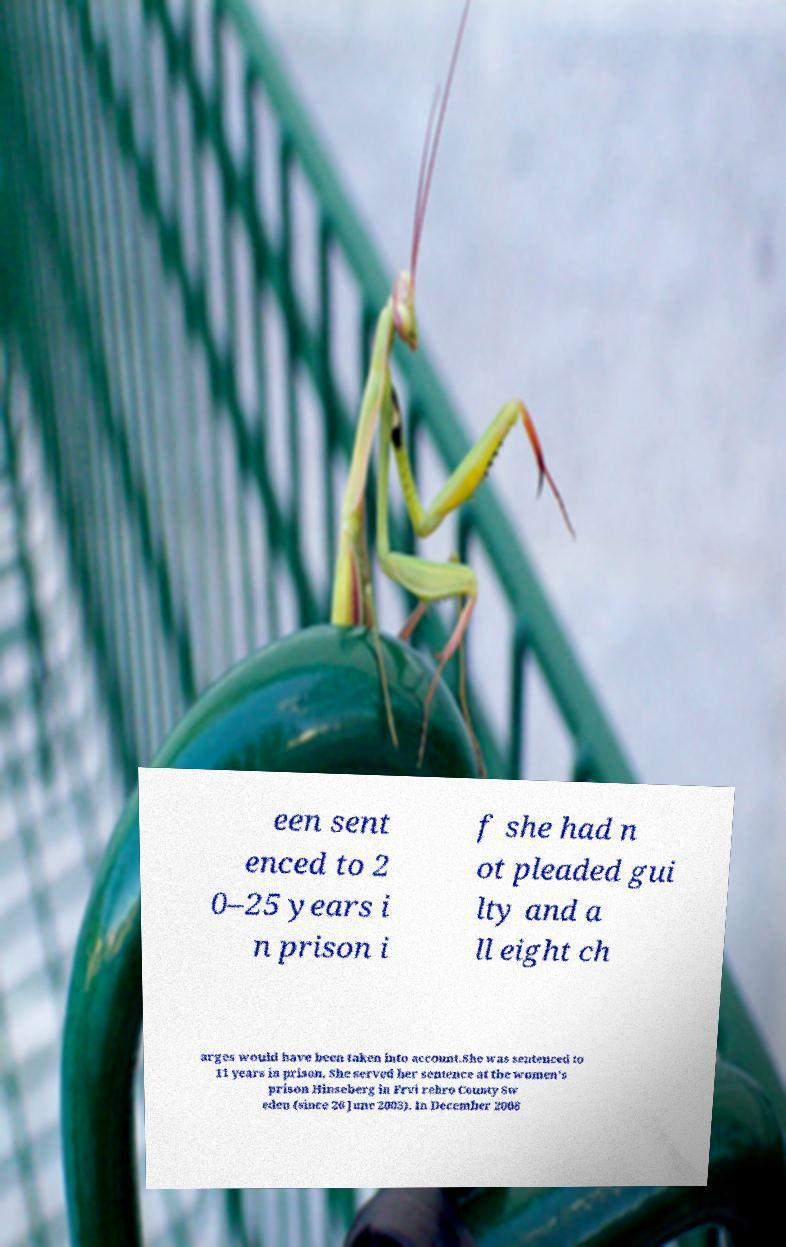What messages or text are displayed in this image? I need them in a readable, typed format. een sent enced to 2 0–25 years i n prison i f she had n ot pleaded gui lty and a ll eight ch arges would have been taken into account.She was sentenced to 11 years in prison. She served her sentence at the women's prison Hinseberg in Frvi rebro County Sw eden (since 26 June 2003). In December 2008 